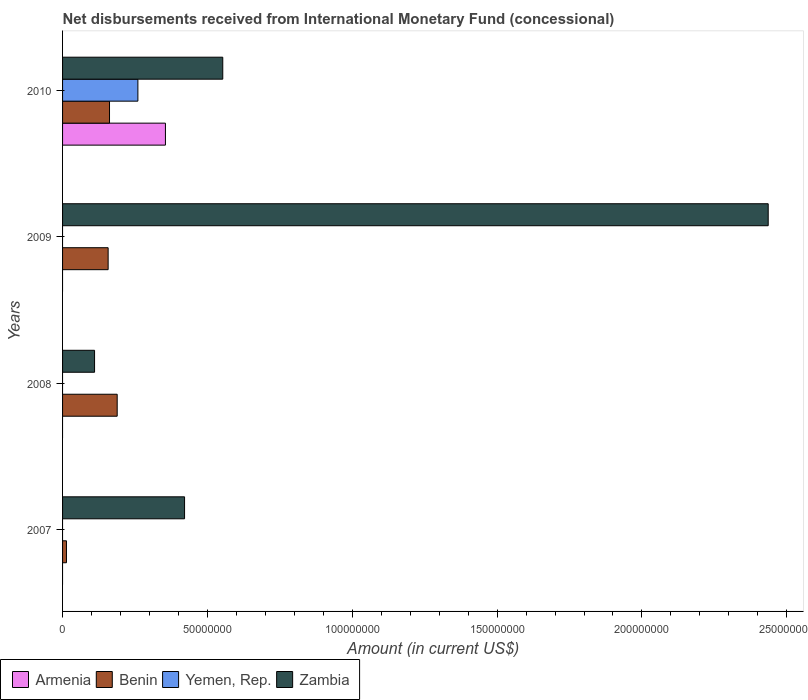Are the number of bars on each tick of the Y-axis equal?
Your response must be concise. No. How many bars are there on the 2nd tick from the top?
Keep it short and to the point. 2. What is the label of the 4th group of bars from the top?
Make the answer very short. 2007. In how many cases, is the number of bars for a given year not equal to the number of legend labels?
Offer a very short reply. 3. What is the amount of disbursements received from International Monetary Fund in Zambia in 2010?
Provide a succinct answer. 5.53e+07. Across all years, what is the maximum amount of disbursements received from International Monetary Fund in Zambia?
Provide a succinct answer. 2.44e+08. Across all years, what is the minimum amount of disbursements received from International Monetary Fund in Benin?
Offer a very short reply. 1.35e+06. In which year was the amount of disbursements received from International Monetary Fund in Zambia maximum?
Your response must be concise. 2009. What is the total amount of disbursements received from International Monetary Fund in Benin in the graph?
Provide a succinct answer. 5.21e+07. What is the difference between the amount of disbursements received from International Monetary Fund in Zambia in 2008 and that in 2009?
Provide a succinct answer. -2.33e+08. What is the difference between the amount of disbursements received from International Monetary Fund in Zambia in 2009 and the amount of disbursements received from International Monetary Fund in Yemen, Rep. in 2007?
Offer a terse response. 2.44e+08. What is the average amount of disbursements received from International Monetary Fund in Zambia per year?
Your answer should be very brief. 8.80e+07. In the year 2010, what is the difference between the amount of disbursements received from International Monetary Fund in Armenia and amount of disbursements received from International Monetary Fund in Benin?
Offer a very short reply. 1.93e+07. What is the ratio of the amount of disbursements received from International Monetary Fund in Zambia in 2009 to that in 2010?
Provide a succinct answer. 4.4. Is the amount of disbursements received from International Monetary Fund in Zambia in 2009 less than that in 2010?
Offer a very short reply. No. What is the difference between the highest and the second highest amount of disbursements received from International Monetary Fund in Benin?
Ensure brevity in your answer.  2.65e+06. What is the difference between the highest and the lowest amount of disbursements received from International Monetary Fund in Yemen, Rep.?
Your answer should be very brief. 2.60e+07. In how many years, is the amount of disbursements received from International Monetary Fund in Armenia greater than the average amount of disbursements received from International Monetary Fund in Armenia taken over all years?
Ensure brevity in your answer.  1. Is the sum of the amount of disbursements received from International Monetary Fund in Zambia in 2007 and 2010 greater than the maximum amount of disbursements received from International Monetary Fund in Benin across all years?
Keep it short and to the point. Yes. Is it the case that in every year, the sum of the amount of disbursements received from International Monetary Fund in Zambia and amount of disbursements received from International Monetary Fund in Yemen, Rep. is greater than the sum of amount of disbursements received from International Monetary Fund in Benin and amount of disbursements received from International Monetary Fund in Armenia?
Your answer should be very brief. No. What is the difference between two consecutive major ticks on the X-axis?
Provide a short and direct response. 5.00e+07. Are the values on the major ticks of X-axis written in scientific E-notation?
Offer a very short reply. No. Where does the legend appear in the graph?
Provide a short and direct response. Bottom left. How many legend labels are there?
Your response must be concise. 4. How are the legend labels stacked?
Make the answer very short. Horizontal. What is the title of the graph?
Your answer should be very brief. Net disbursements received from International Monetary Fund (concessional). What is the label or title of the X-axis?
Provide a succinct answer. Amount (in current US$). What is the Amount (in current US$) of Benin in 2007?
Your answer should be very brief. 1.35e+06. What is the Amount (in current US$) in Yemen, Rep. in 2007?
Ensure brevity in your answer.  0. What is the Amount (in current US$) in Zambia in 2007?
Offer a very short reply. 4.21e+07. What is the Amount (in current US$) in Armenia in 2008?
Your answer should be compact. 0. What is the Amount (in current US$) of Benin in 2008?
Your answer should be compact. 1.89e+07. What is the Amount (in current US$) of Zambia in 2008?
Offer a terse response. 1.10e+07. What is the Amount (in current US$) of Armenia in 2009?
Provide a short and direct response. 0. What is the Amount (in current US$) of Benin in 2009?
Offer a terse response. 1.57e+07. What is the Amount (in current US$) in Yemen, Rep. in 2009?
Your answer should be compact. 0. What is the Amount (in current US$) of Zambia in 2009?
Give a very brief answer. 2.44e+08. What is the Amount (in current US$) in Armenia in 2010?
Make the answer very short. 3.55e+07. What is the Amount (in current US$) in Benin in 2010?
Your response must be concise. 1.62e+07. What is the Amount (in current US$) of Yemen, Rep. in 2010?
Your answer should be very brief. 2.60e+07. What is the Amount (in current US$) in Zambia in 2010?
Provide a short and direct response. 5.53e+07. Across all years, what is the maximum Amount (in current US$) of Armenia?
Ensure brevity in your answer.  3.55e+07. Across all years, what is the maximum Amount (in current US$) in Benin?
Your response must be concise. 1.89e+07. Across all years, what is the maximum Amount (in current US$) in Yemen, Rep.?
Your answer should be very brief. 2.60e+07. Across all years, what is the maximum Amount (in current US$) of Zambia?
Offer a terse response. 2.44e+08. Across all years, what is the minimum Amount (in current US$) of Benin?
Provide a short and direct response. 1.35e+06. Across all years, what is the minimum Amount (in current US$) in Zambia?
Your answer should be compact. 1.10e+07. What is the total Amount (in current US$) of Armenia in the graph?
Your answer should be very brief. 3.55e+07. What is the total Amount (in current US$) of Benin in the graph?
Provide a short and direct response. 5.21e+07. What is the total Amount (in current US$) in Yemen, Rep. in the graph?
Your answer should be compact. 2.60e+07. What is the total Amount (in current US$) of Zambia in the graph?
Your response must be concise. 3.52e+08. What is the difference between the Amount (in current US$) in Benin in 2007 and that in 2008?
Provide a short and direct response. -1.75e+07. What is the difference between the Amount (in current US$) in Zambia in 2007 and that in 2008?
Offer a terse response. 3.11e+07. What is the difference between the Amount (in current US$) in Benin in 2007 and that in 2009?
Ensure brevity in your answer.  -1.44e+07. What is the difference between the Amount (in current US$) in Zambia in 2007 and that in 2009?
Offer a terse response. -2.01e+08. What is the difference between the Amount (in current US$) in Benin in 2007 and that in 2010?
Offer a very short reply. -1.49e+07. What is the difference between the Amount (in current US$) in Zambia in 2007 and that in 2010?
Ensure brevity in your answer.  -1.32e+07. What is the difference between the Amount (in current US$) in Benin in 2008 and that in 2009?
Your response must be concise. 3.12e+06. What is the difference between the Amount (in current US$) of Zambia in 2008 and that in 2009?
Your response must be concise. -2.33e+08. What is the difference between the Amount (in current US$) in Benin in 2008 and that in 2010?
Keep it short and to the point. 2.65e+06. What is the difference between the Amount (in current US$) of Zambia in 2008 and that in 2010?
Your answer should be compact. -4.43e+07. What is the difference between the Amount (in current US$) in Benin in 2009 and that in 2010?
Your response must be concise. -4.72e+05. What is the difference between the Amount (in current US$) in Zambia in 2009 and that in 2010?
Provide a succinct answer. 1.88e+08. What is the difference between the Amount (in current US$) in Benin in 2007 and the Amount (in current US$) in Zambia in 2008?
Offer a terse response. -9.70e+06. What is the difference between the Amount (in current US$) in Benin in 2007 and the Amount (in current US$) in Zambia in 2009?
Keep it short and to the point. -2.42e+08. What is the difference between the Amount (in current US$) in Benin in 2007 and the Amount (in current US$) in Yemen, Rep. in 2010?
Your answer should be very brief. -2.47e+07. What is the difference between the Amount (in current US$) in Benin in 2007 and the Amount (in current US$) in Zambia in 2010?
Ensure brevity in your answer.  -5.40e+07. What is the difference between the Amount (in current US$) of Benin in 2008 and the Amount (in current US$) of Zambia in 2009?
Ensure brevity in your answer.  -2.25e+08. What is the difference between the Amount (in current US$) in Benin in 2008 and the Amount (in current US$) in Yemen, Rep. in 2010?
Provide a short and direct response. -7.14e+06. What is the difference between the Amount (in current US$) of Benin in 2008 and the Amount (in current US$) of Zambia in 2010?
Your response must be concise. -3.64e+07. What is the difference between the Amount (in current US$) of Benin in 2009 and the Amount (in current US$) of Yemen, Rep. in 2010?
Provide a short and direct response. -1.03e+07. What is the difference between the Amount (in current US$) of Benin in 2009 and the Amount (in current US$) of Zambia in 2010?
Give a very brief answer. -3.96e+07. What is the average Amount (in current US$) of Armenia per year?
Your answer should be very brief. 8.88e+06. What is the average Amount (in current US$) in Benin per year?
Offer a terse response. 1.30e+07. What is the average Amount (in current US$) in Yemen, Rep. per year?
Ensure brevity in your answer.  6.50e+06. What is the average Amount (in current US$) of Zambia per year?
Make the answer very short. 8.80e+07. In the year 2007, what is the difference between the Amount (in current US$) of Benin and Amount (in current US$) of Zambia?
Provide a short and direct response. -4.08e+07. In the year 2008, what is the difference between the Amount (in current US$) in Benin and Amount (in current US$) in Zambia?
Your answer should be very brief. 7.81e+06. In the year 2009, what is the difference between the Amount (in current US$) of Benin and Amount (in current US$) of Zambia?
Ensure brevity in your answer.  -2.28e+08. In the year 2010, what is the difference between the Amount (in current US$) of Armenia and Amount (in current US$) of Benin?
Offer a terse response. 1.93e+07. In the year 2010, what is the difference between the Amount (in current US$) of Armenia and Amount (in current US$) of Yemen, Rep.?
Provide a short and direct response. 9.51e+06. In the year 2010, what is the difference between the Amount (in current US$) of Armenia and Amount (in current US$) of Zambia?
Offer a terse response. -1.98e+07. In the year 2010, what is the difference between the Amount (in current US$) of Benin and Amount (in current US$) of Yemen, Rep.?
Keep it short and to the point. -9.80e+06. In the year 2010, what is the difference between the Amount (in current US$) in Benin and Amount (in current US$) in Zambia?
Make the answer very short. -3.91e+07. In the year 2010, what is the difference between the Amount (in current US$) in Yemen, Rep. and Amount (in current US$) in Zambia?
Your answer should be compact. -2.93e+07. What is the ratio of the Amount (in current US$) of Benin in 2007 to that in 2008?
Offer a very short reply. 0.07. What is the ratio of the Amount (in current US$) in Zambia in 2007 to that in 2008?
Provide a succinct answer. 3.81. What is the ratio of the Amount (in current US$) of Benin in 2007 to that in 2009?
Make the answer very short. 0.09. What is the ratio of the Amount (in current US$) of Zambia in 2007 to that in 2009?
Keep it short and to the point. 0.17. What is the ratio of the Amount (in current US$) of Benin in 2007 to that in 2010?
Ensure brevity in your answer.  0.08. What is the ratio of the Amount (in current US$) in Zambia in 2007 to that in 2010?
Provide a succinct answer. 0.76. What is the ratio of the Amount (in current US$) of Benin in 2008 to that in 2009?
Make the answer very short. 1.2. What is the ratio of the Amount (in current US$) of Zambia in 2008 to that in 2009?
Make the answer very short. 0.05. What is the ratio of the Amount (in current US$) in Benin in 2008 to that in 2010?
Provide a succinct answer. 1.16. What is the ratio of the Amount (in current US$) in Zambia in 2008 to that in 2010?
Make the answer very short. 0.2. What is the ratio of the Amount (in current US$) of Benin in 2009 to that in 2010?
Provide a short and direct response. 0.97. What is the ratio of the Amount (in current US$) of Zambia in 2009 to that in 2010?
Provide a short and direct response. 4.4. What is the difference between the highest and the second highest Amount (in current US$) in Benin?
Provide a short and direct response. 2.65e+06. What is the difference between the highest and the second highest Amount (in current US$) of Zambia?
Your answer should be compact. 1.88e+08. What is the difference between the highest and the lowest Amount (in current US$) in Armenia?
Offer a terse response. 3.55e+07. What is the difference between the highest and the lowest Amount (in current US$) in Benin?
Your answer should be very brief. 1.75e+07. What is the difference between the highest and the lowest Amount (in current US$) in Yemen, Rep.?
Offer a terse response. 2.60e+07. What is the difference between the highest and the lowest Amount (in current US$) in Zambia?
Provide a succinct answer. 2.33e+08. 